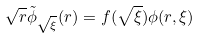Convert formula to latex. <formula><loc_0><loc_0><loc_500><loc_500>\sqrt { r } \tilde { \phi } _ { \sqrt { \xi } } ( r ) = f ( \sqrt { \xi } ) \phi ( r , \xi )</formula> 